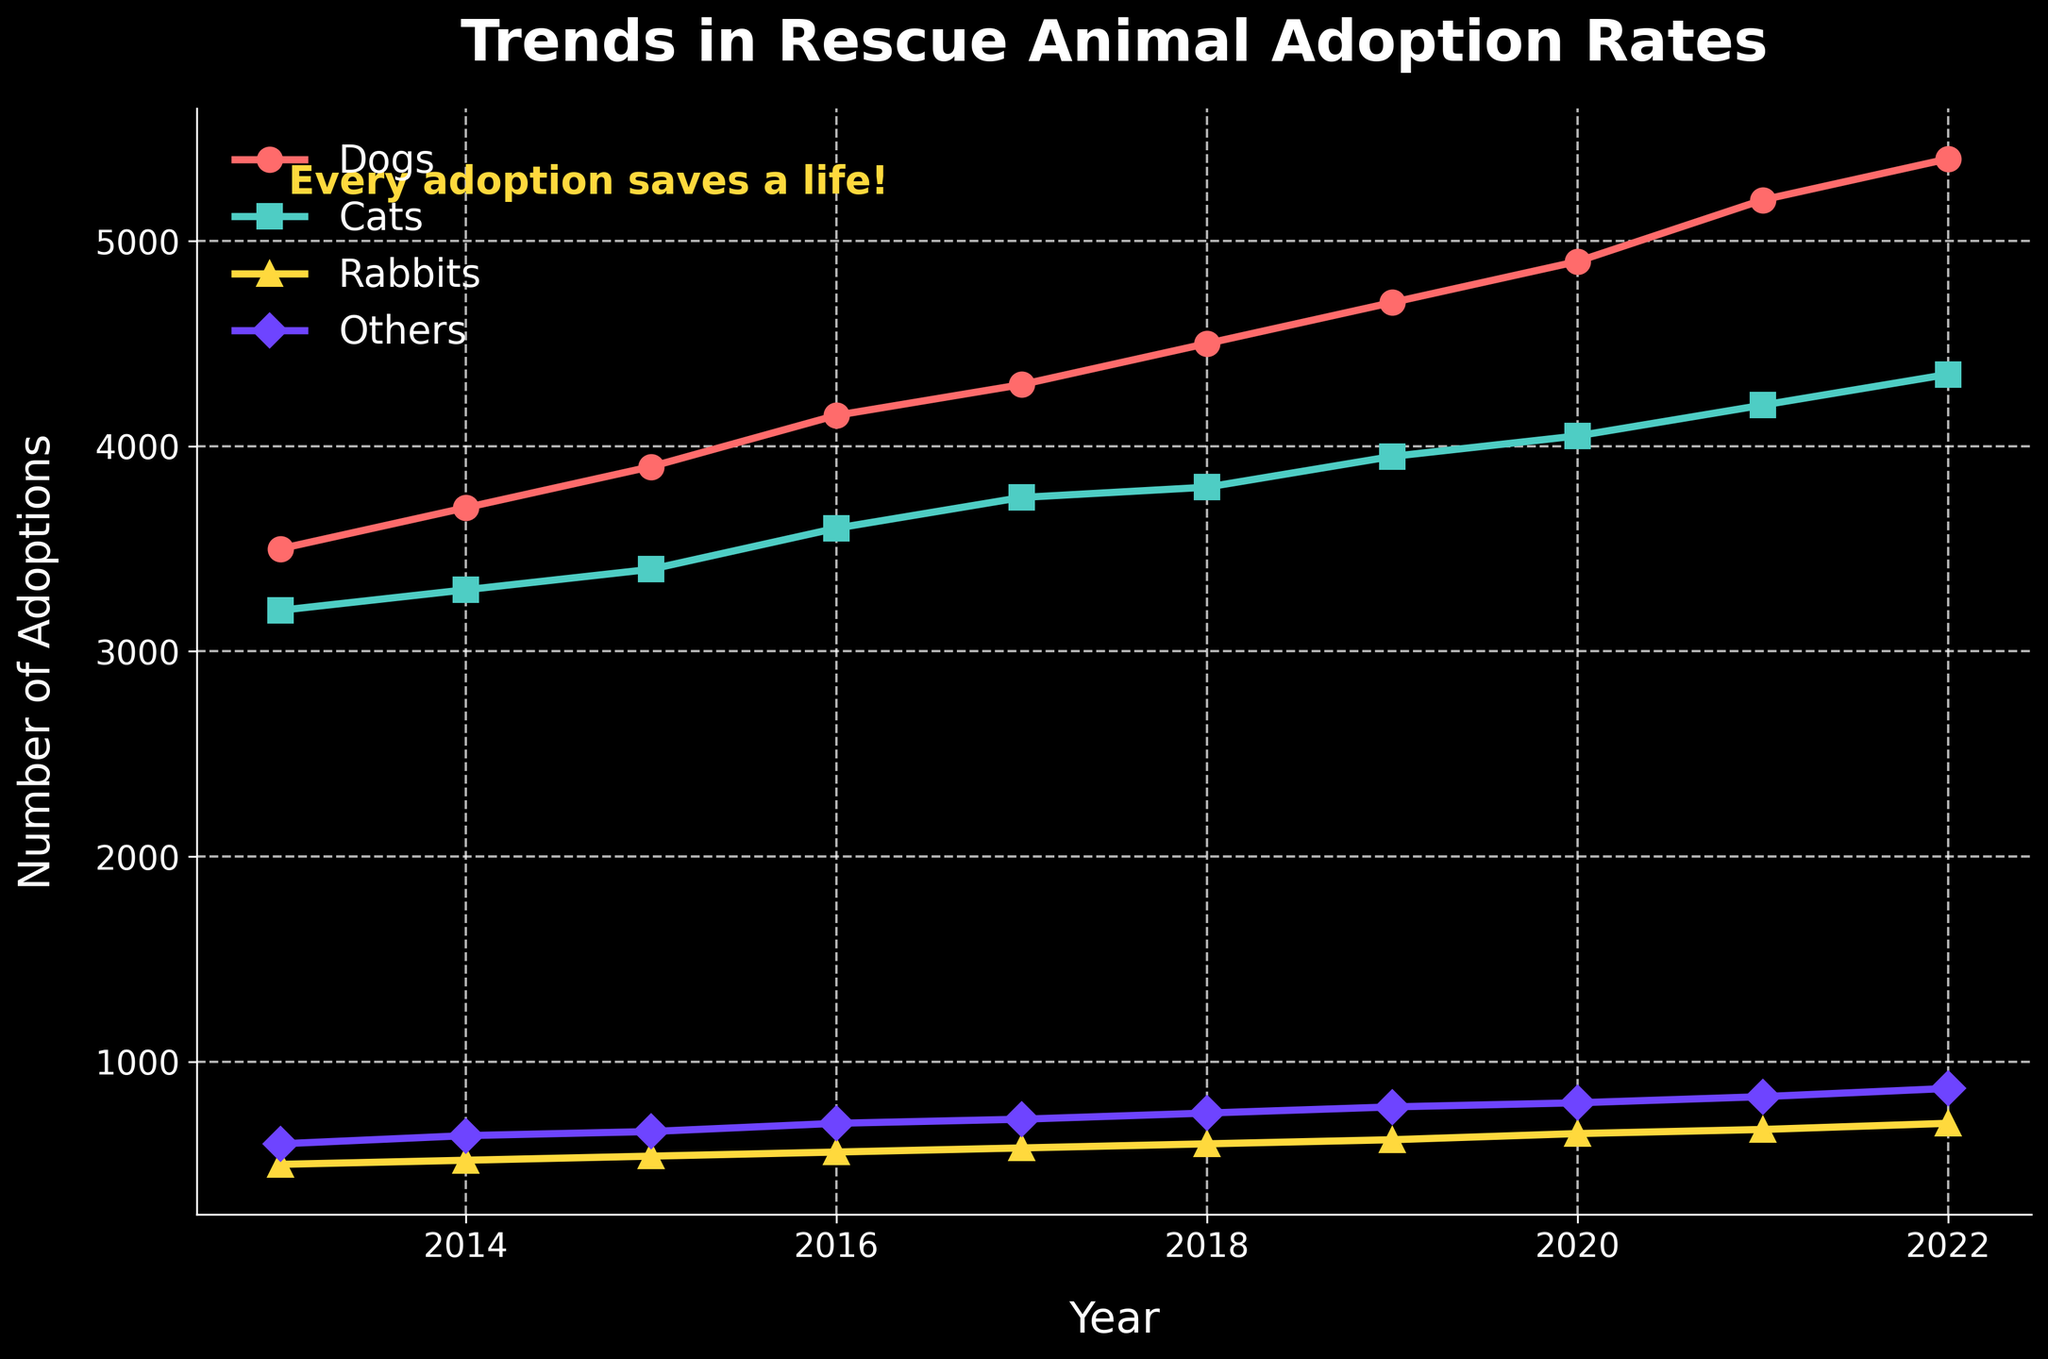What is the title of the plot? The title of the plot is displayed at the top and reads "Trends in Rescue Animal Adoption Rates".
Answer: Trends in Rescue Animal Adoption Rates What are the labels on the x-axis and y-axis? The labels are written beside the axes. The x-axis is labeled "Year" and the y-axis is labeled "Number of Adoptions".
Answer: Year, Number of Adoptions Which animal had the highest number of adoptions in 2022? Look at the data points corresponding to 2022 and compare the values for each animal. Dogs had the highest number of adoptions with 5400 adoptions.
Answer: Dogs How many adoptions of rabbits were there in 2016? Locate the data point for rabbits in the year 2016 on the plot. The number of adoptions for rabbits in 2016 is 560.
Answer: 560 How did the number of cat adoptions change from 2013 to 2022? Inspect the endpoints for cats at the years 2013 and 2022. In 2013, there were 3200 adoptions and in 2022, there were 4350 adoptions. This shows an increase of 1150 adoptions over this period.
Answer: Increased by 1150 Which other animal besides dogs saw an upward trend in adoptions from 2013 to 2022? Observe the trend lines for each animal from 2013 to 2022. Both cats, rabbits, and others besides dogs show an upward trend in adoptions.
Answer: Cats, Rabbits, Others What was the approximate average number of rabbit adoptions per year over the decade? Sum up the yearly adoption numbers for rabbits and then divide by 10 to get the average. (500 + 520 + 540 + 560 + 580 + 600 + 620 + 650 + 670 + 700) / 10 = 594
Answer: 594 In which year did the number of dog adoptions first exceed 4500? Look at the trend line for dogs and identify the first year that the adoption number crossed 4500. This occurred in 2018.
Answer: 2018 Comparing the increase in adoptions from 2013 to 2022, which animal had the smallest growth? Calculate the difference from 2013 to 2022 for each animal. Dogs: 5400-3500 = 1900, Cats: 4350-3200 = 1150, Rabbits: 700-500 = 200, Others: 870-600 = 270. Rabbits had the smallest growth with an increase of 200.
Answer: Rabbits 